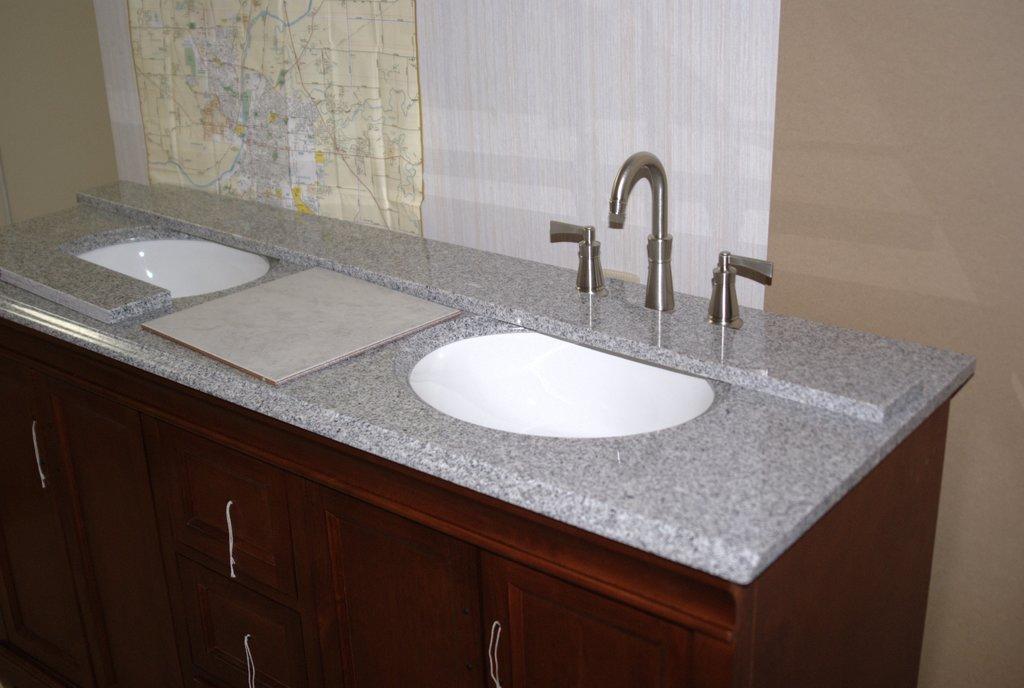Please provide a concise description of this image. In this image there are two sinks and a tap, below the sink there are cupboards. In the background there is a wall and a map is attached to it. 